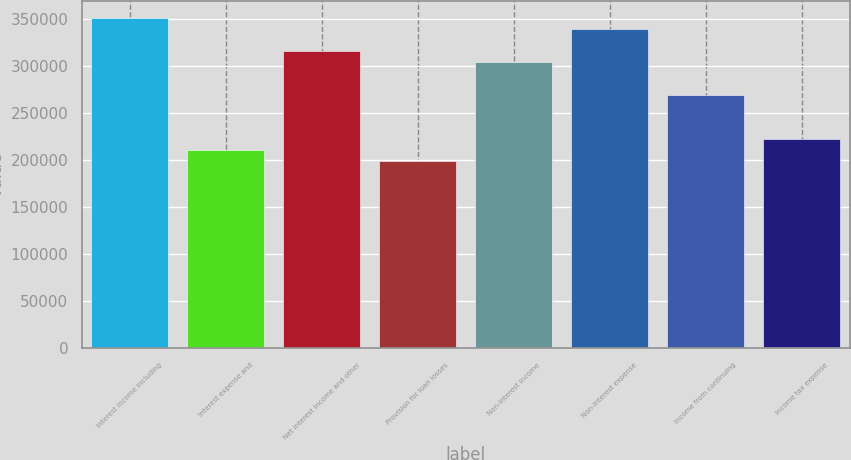Convert chart. <chart><loc_0><loc_0><loc_500><loc_500><bar_chart><fcel>Interest income including<fcel>Interest expense and<fcel>Net interest income and other<fcel>Provision for loan losses<fcel>Non-interest income<fcel>Non-interest expense<fcel>Income from continuing<fcel>Income tax expense<nl><fcel>351862<fcel>211118<fcel>316676<fcel>199389<fcel>304948<fcel>340134<fcel>269761<fcel>222847<nl></chart> 